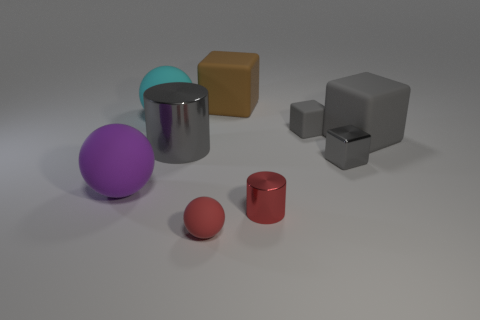What material is the other big object that is the same shape as the big gray matte thing?
Keep it short and to the point. Rubber. Are the big cube right of the tiny gray shiny block and the tiny cylinder made of the same material?
Provide a succinct answer. No. Are there more rubber blocks that are right of the small cylinder than big gray rubber blocks left of the small red matte thing?
Your answer should be compact. Yes. What is the size of the red metal cylinder?
Keep it short and to the point. Small. There is a small object that is the same material as the small red sphere; what is its shape?
Provide a short and direct response. Cube. There is a rubber object that is behind the big cyan rubber ball; does it have the same shape as the small gray rubber thing?
Your answer should be very brief. Yes. How many objects are purple things or small cubes?
Your answer should be very brief. 3. There is a thing that is on the left side of the shiny block and to the right of the tiny red metal cylinder; what is its material?
Make the answer very short. Rubber. Is the size of the purple thing the same as the cyan ball?
Give a very brief answer. Yes. There is a cylinder right of the object that is behind the large cyan thing; how big is it?
Your answer should be compact. Small. 